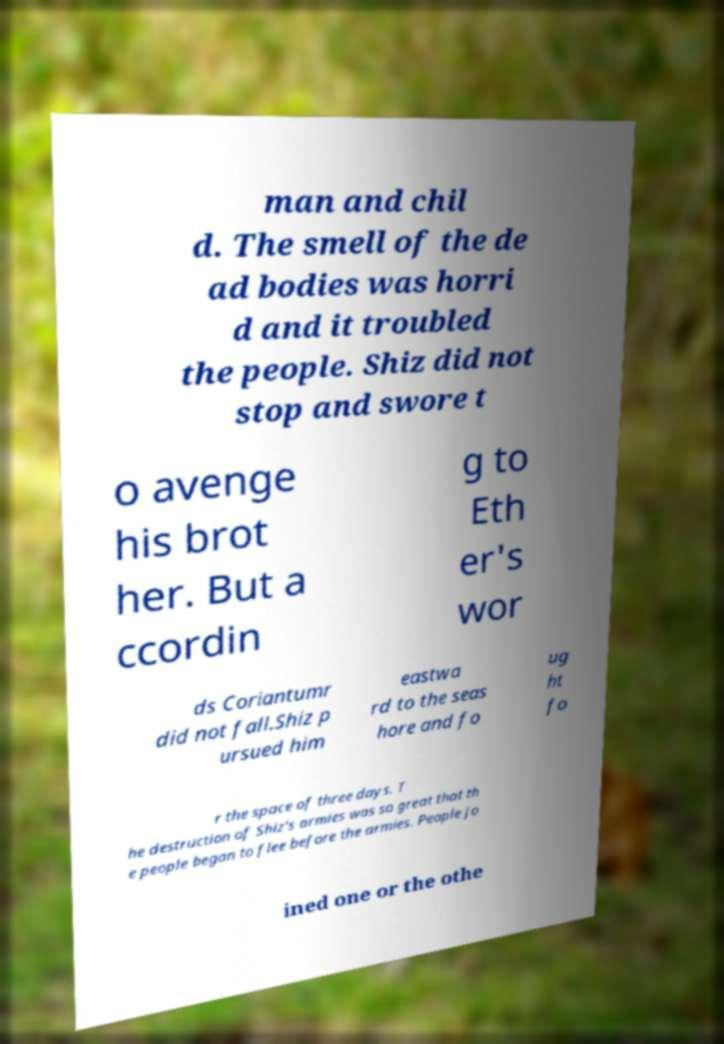Could you extract and type out the text from this image? man and chil d. The smell of the de ad bodies was horri d and it troubled the people. Shiz did not stop and swore t o avenge his brot her. But a ccordin g to Eth er's wor ds Coriantumr did not fall.Shiz p ursued him eastwa rd to the seas hore and fo ug ht fo r the space of three days. T he destruction of Shiz's armies was so great that th e people began to flee before the armies. People jo ined one or the othe 